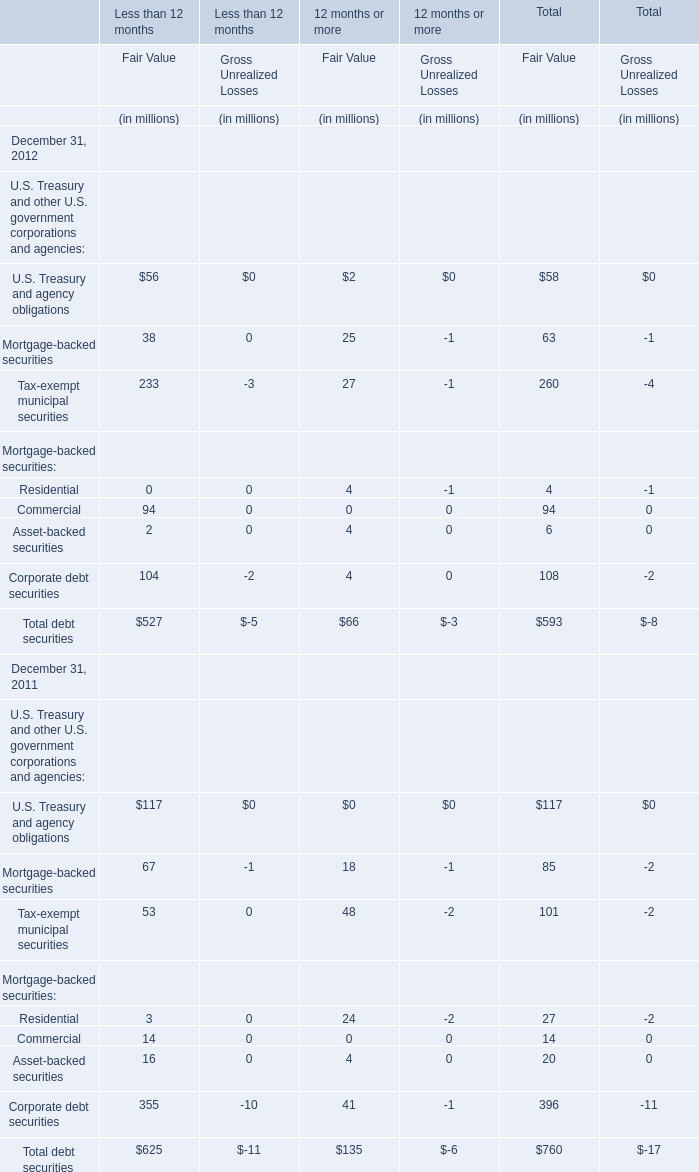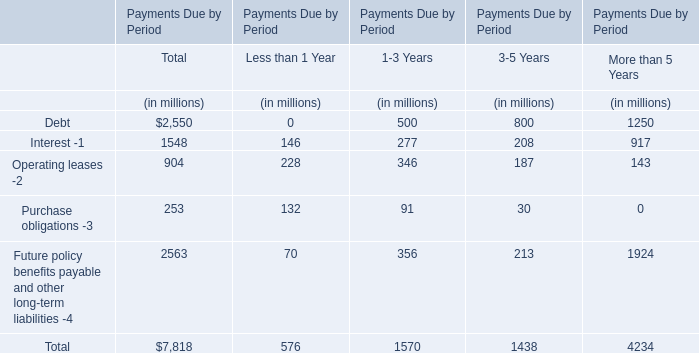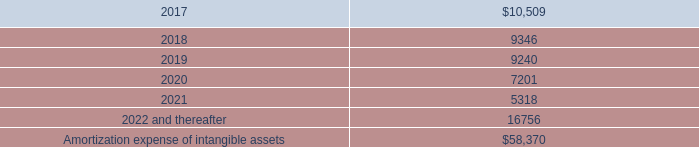what was the difference in millions of amortization expense between 2015 and 2016? 
Computations: (13.0 - 13.9)
Answer: -0.9. 